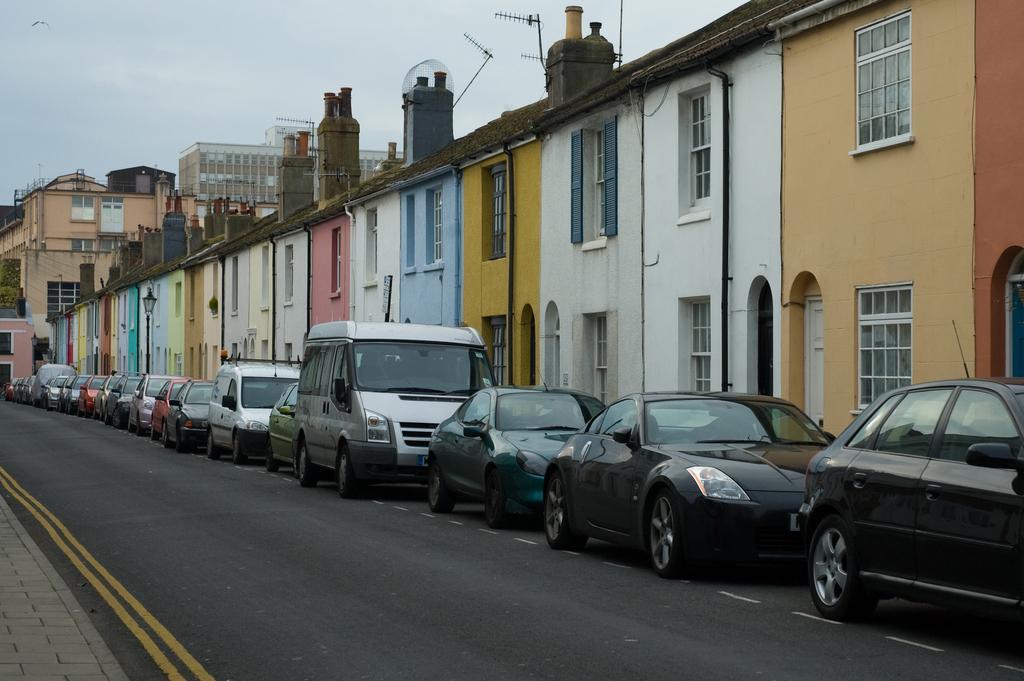Can you describe this image briefly? In this picture we can see some vehicles, on the right side there are some buildings, there is road at the bottom, we can see the sky at the top of the picture, there is a pole and a light in the middle, we can see pipes of these buildings. 